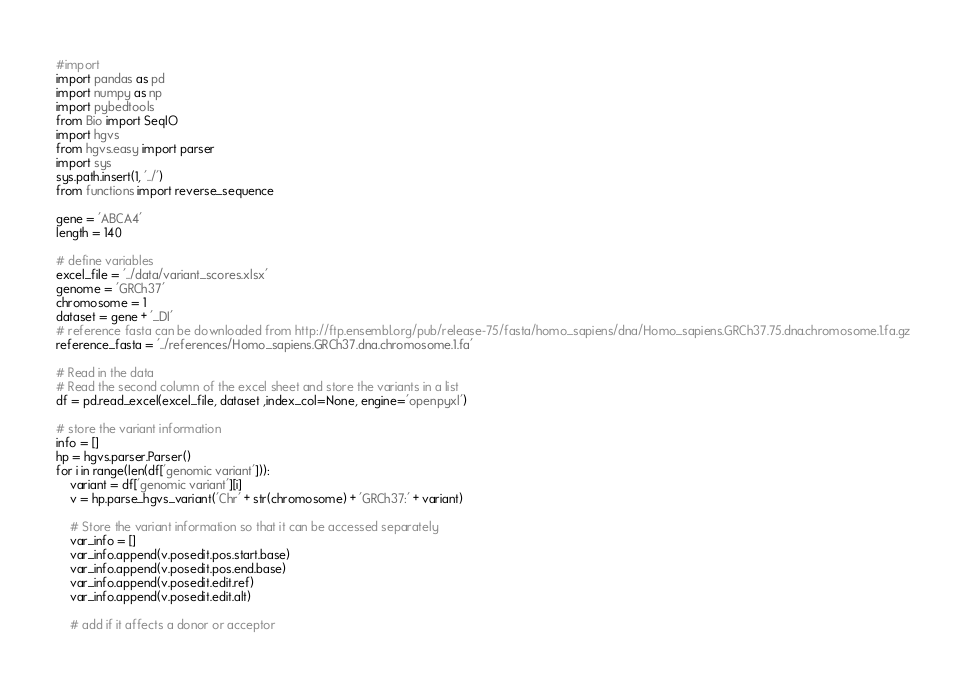<code> <loc_0><loc_0><loc_500><loc_500><_Python_>#import
import pandas as pd
import numpy as np
import pybedtools
from Bio import SeqIO
import hgvs
from hgvs.easy import parser
import sys
sys.path.insert(1, '../')
from functions import reverse_sequence

gene = 'ABCA4'
length = 140

# define variables
excel_file = '../data/variant_scores.xlsx'
genome = 'GRCh37'
chromosome = 1
dataset = gene + '_DI'
# reference fasta can be downloaded from http://ftp.ensembl.org/pub/release-75/fasta/homo_sapiens/dna/Homo_sapiens.GRCh37.75.dna.chromosome.1.fa.gz
reference_fasta = '../references/Homo_sapiens.GRCh37.dna.chromosome.1.fa'

# Read in the data 
# Read the second column of the excel sheet and store the variants in a list
df = pd.read_excel(excel_file, dataset ,index_col=None, engine='openpyxl')

# store the variant information
info = []
hp = hgvs.parser.Parser()
for i in range(len(df['genomic variant'])):
    variant = df['genomic variant'][i]
    v = hp.parse_hgvs_variant('Chr' + str(chromosome) + 'GRCh37:' + variant)
    
    # Store the variant information so that it can be accessed separately
    var_info = []
    var_info.append(v.posedit.pos.start.base)
    var_info.append(v.posedit.pos.end.base)
    var_info.append(v.posedit.edit.ref)
    var_info.append(v.posedit.edit.alt)
    
    # add if it affects a donor or acceptor</code> 